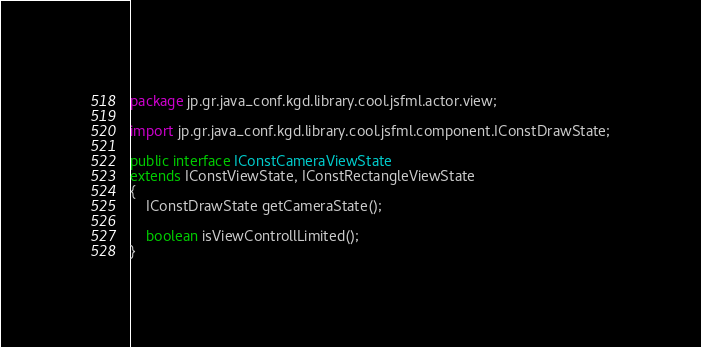Convert code to text. <code><loc_0><loc_0><loc_500><loc_500><_Java_>package jp.gr.java_conf.kgd.library.cool.jsfml.actor.view;

import jp.gr.java_conf.kgd.library.cool.jsfml.component.IConstDrawState;

public interface IConstCameraViewState
extends IConstViewState, IConstRectangleViewState
{
	IConstDrawState getCameraState();
	
	boolean isViewControllLimited();
}
</code> 